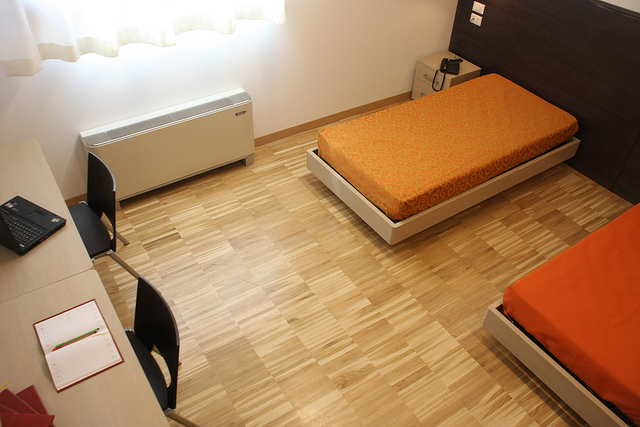<image>What is the name of the hotel? I don't know the name of the hotel. It could be either budget hotel, marriott, hilton, omni, or radisson. What is the name of the hotel? I don't know what is the name of the hotel. It can be either 'budget hotel', 'marriott', 'hilton', 'omni', or 'radisson'. 